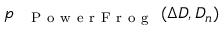<formula> <loc_0><loc_0><loc_500><loc_500>p _ { { P o w e r F r o g } } ( \Delta D , D _ { n } )</formula> 